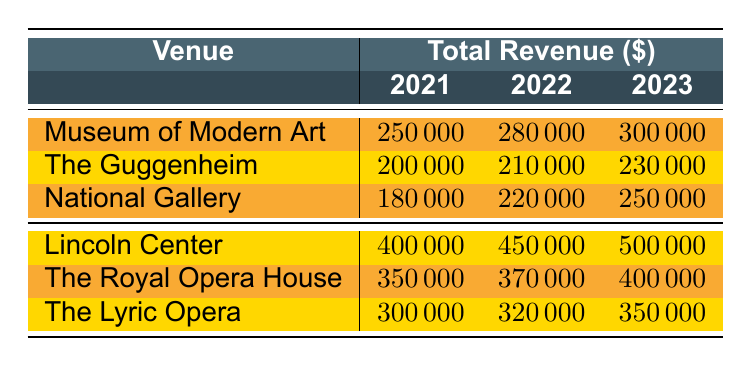What was the total revenue from the Museum of Modern Art in 2022? The table lists the total revenue for the Museum of Modern Art in 2022 as 280,000.
Answer: 280000 What is the total revenue from all venues in 2021? To find the total revenue for all venues in 2021, we sum the total revenues: 250,000 + 200,000 + 180,000 + 400,000 + 350,000 + 300,000 = 1,680,000.
Answer: 1680000 Which venue had the highest revenue in 2023? By comparing the total revenues for 2023, Lincoln Center has the highest revenue at 500,000.
Answer: Lincoln Center What was the difference in total revenue for The Guggenheim between 2021 and 2023? The total revenue for The Guggenheim in 2021 was 200,000 and in 2023 it was 230,000. The difference is 230,000 - 200,000 = 30,000.
Answer: 30000 What is the average total revenue for the National Gallery over the three years? The total revenues for the National Gallery are 180,000 (2021), 220,000 (2022), and 250,000 (2023). The average is (180,000 + 220,000 + 250,000) / 3 = 216,667.
Answer: 216667 Did the total revenue for The Royal Opera House increase from 2021 to 2023? The total revenue for The Royal Opera House was 350,000 in 2021 and 400,000 in 2023, indicating an increase. Yes, it increased.
Answer: Yes What is the total revenue for all exhibitions in 2022? To find the total revenue for exhibitions in 2022, sum the revenues: 280,000 (Museum of Modern Art) + 210,000 (The Guggenheim) + 220,000 (National Gallery) = 710,000.
Answer: 710000 How much more did Lincoln Center earn than The Lyric Opera in 2023? Lincoln Center earned 500,000 and The Lyric Opera earned 350,000 in 2023. The difference is 500,000 - 350,000 = 150,000.
Answer: 150000 What trend can be observed in the total revenue for the National Gallery from 2021 to 2023? The total revenue for the National Gallery increased consistently from 180,000 in 2021 to 250,000 in 2023. Thus, the trend shows a steady increase.
Answer: Steady increase Which venue had the lowest total revenue in 2021? In 2021, the venue with the lowest total revenue is The Lyric Opera, with a total revenue of 300,000.
Answer: The Lyric Opera 